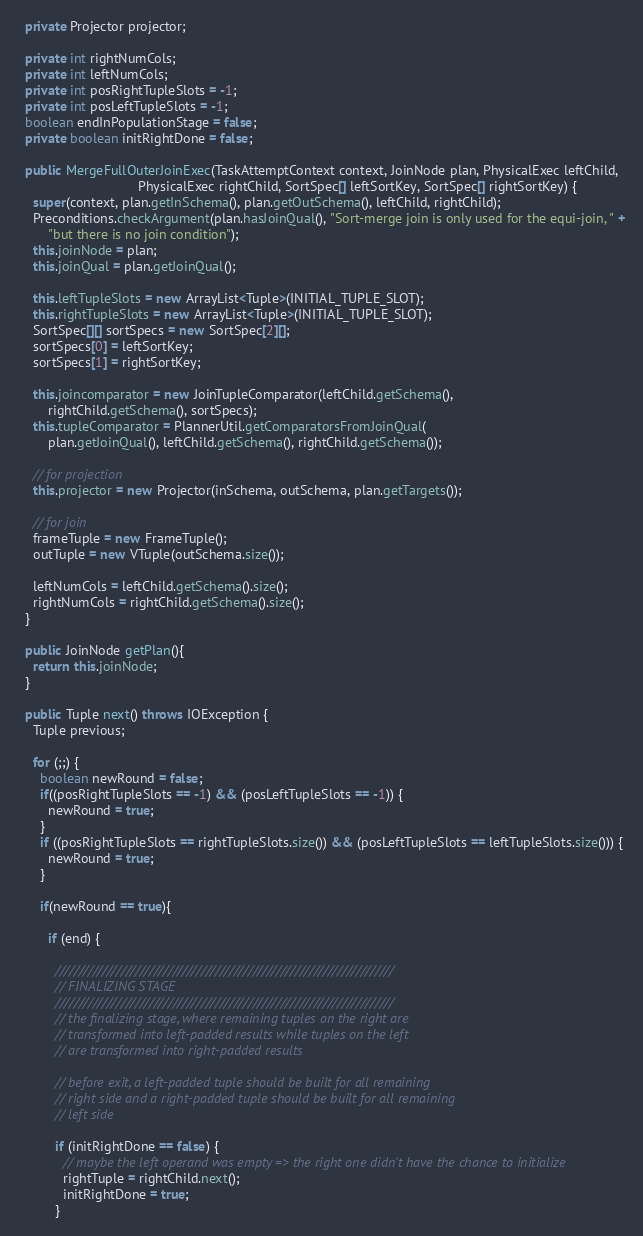<code> <loc_0><loc_0><loc_500><loc_500><_Java_>  private Projector projector;

  private int rightNumCols;
  private int leftNumCols;
  private int posRightTupleSlots = -1;
  private int posLeftTupleSlots = -1;
  boolean endInPopulationStage = false;
  private boolean initRightDone = false;

  public MergeFullOuterJoinExec(TaskAttemptContext context, JoinNode plan, PhysicalExec leftChild,
                                PhysicalExec rightChild, SortSpec[] leftSortKey, SortSpec[] rightSortKey) {
    super(context, plan.getInSchema(), plan.getOutSchema(), leftChild, rightChild);
    Preconditions.checkArgument(plan.hasJoinQual(), "Sort-merge join is only used for the equi-join, " +
        "but there is no join condition");
    this.joinNode = plan;
    this.joinQual = plan.getJoinQual();

    this.leftTupleSlots = new ArrayList<Tuple>(INITIAL_TUPLE_SLOT);
    this.rightTupleSlots = new ArrayList<Tuple>(INITIAL_TUPLE_SLOT);
    SortSpec[][] sortSpecs = new SortSpec[2][];
    sortSpecs[0] = leftSortKey;
    sortSpecs[1] = rightSortKey;

    this.joincomparator = new JoinTupleComparator(leftChild.getSchema(),
        rightChild.getSchema(), sortSpecs);
    this.tupleComparator = PlannerUtil.getComparatorsFromJoinQual(
        plan.getJoinQual(), leftChild.getSchema(), rightChild.getSchema());

    // for projection
    this.projector = new Projector(inSchema, outSchema, plan.getTargets());

    // for join
    frameTuple = new FrameTuple();
    outTuple = new VTuple(outSchema.size());

    leftNumCols = leftChild.getSchema().size();
    rightNumCols = rightChild.getSchema().size();
  }

  public JoinNode getPlan(){
    return this.joinNode;
  }

  public Tuple next() throws IOException {
    Tuple previous;

    for (;;) {
      boolean newRound = false;
      if((posRightTupleSlots == -1) && (posLeftTupleSlots == -1)) {
        newRound = true;
      }
      if ((posRightTupleSlots == rightTupleSlots.size()) && (posLeftTupleSlots == leftTupleSlots.size())) {
        newRound = true;
      }

      if(newRound == true){

        if (end) {

          ////////////////////////////////////////////////////////////////////////
          // FINALIZING STAGE
          ////////////////////////////////////////////////////////////////////////
          // the finalizing stage, where remaining tuples on the right are
          // transformed into left-padded results while tuples on the left
          // are transformed into right-padded results

          // before exit, a left-padded tuple should be built for all remaining
          // right side and a right-padded tuple should be built for all remaining
          // left side

          if (initRightDone == false) {
            // maybe the left operand was empty => the right one didn't have the chance to initialize
            rightTuple = rightChild.next();
            initRightDone = true;
          }
</code> 